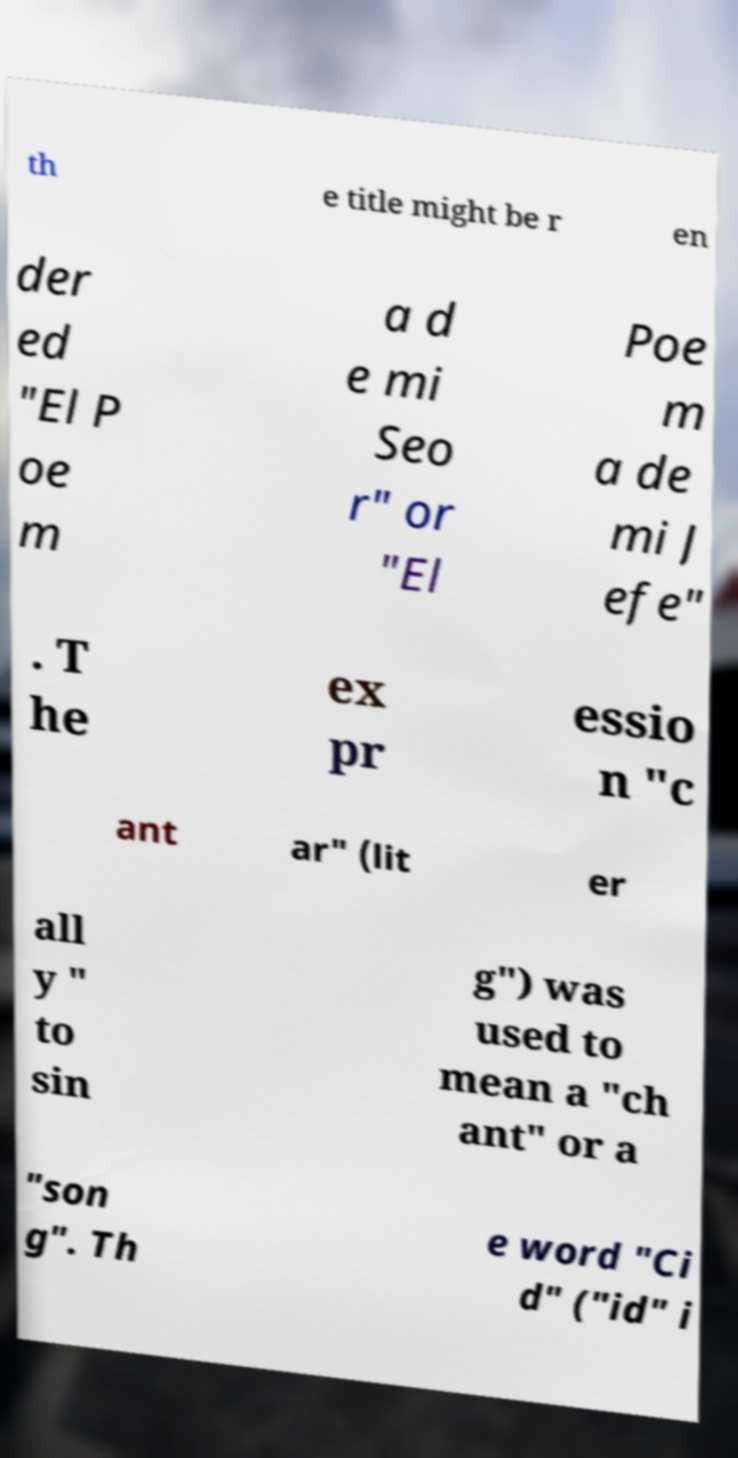For documentation purposes, I need the text within this image transcribed. Could you provide that? th e title might be r en der ed "El P oe m a d e mi Seo r" or "El Poe m a de mi J efe" . T he ex pr essio n "c ant ar" (lit er all y " to sin g") was used to mean a "ch ant" or a "son g". Th e word "Ci d" ("id" i 